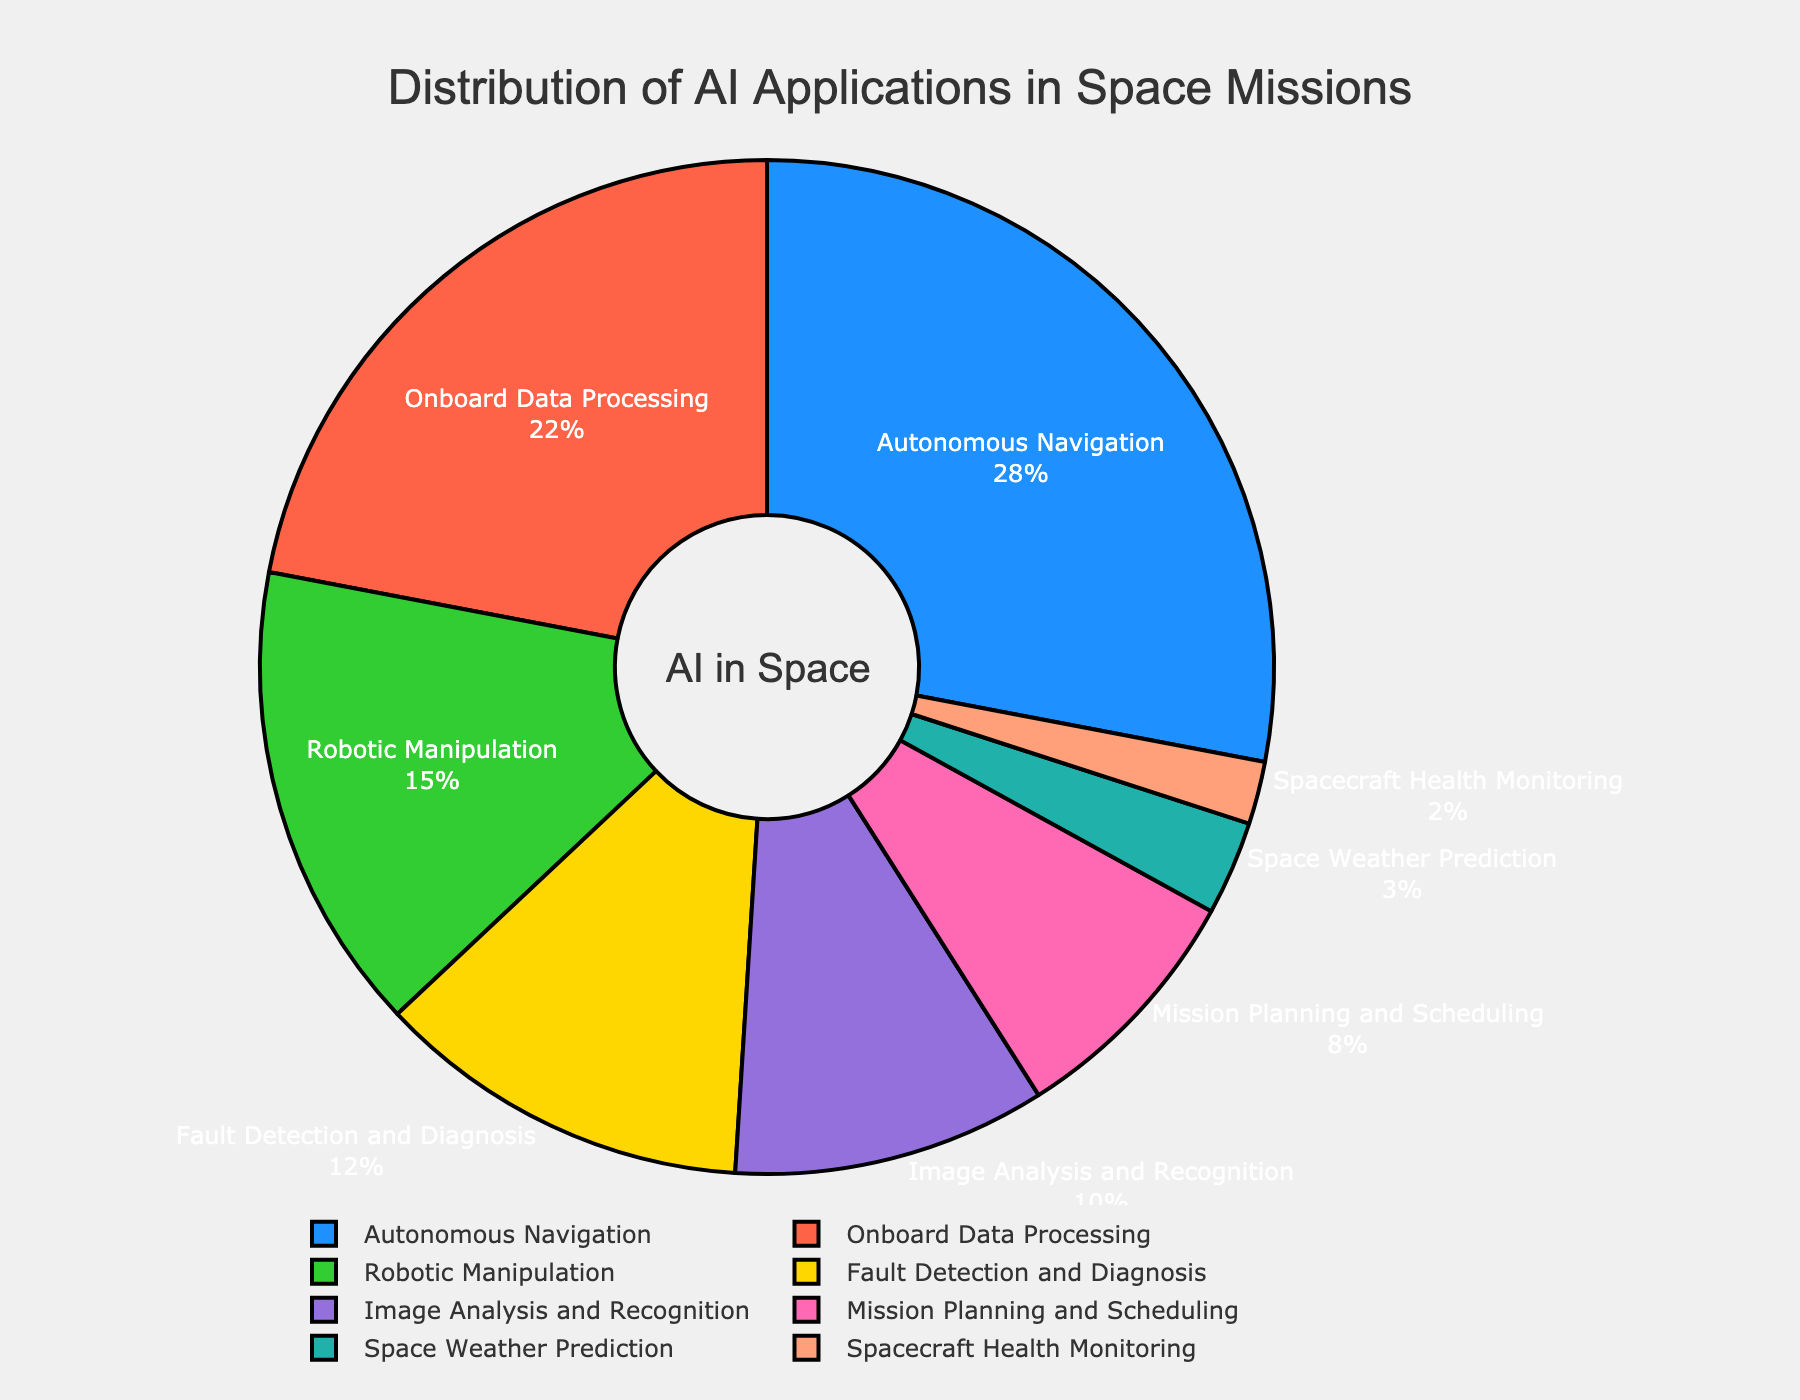What's the most common AI application in space missions? The pie chart labels and percentages show that 'Autonomous Navigation' has the highest percentage of 28%. Compare this to other categories which all have lower percentages.
Answer: Autonomous Navigation Which two applications combined make up exactly half of the AI applications in space missions? Adding the percentages of 'Autonomous Navigation' (28%) and 'Onboard Data Processing' (22%) results in 50%.
Answer: Autonomous Navigation and Onboard Data Processing What is the combined percentage of 'Robotic Manipulation' and 'Image Analysis and Recognition'? The pie chart shows 'Robotic Manipulation' at 15% and 'Image Analysis and Recognition' at 10%. Adding these gives 15% + 10% = 25%.
Answer: 25% Which category has a larger percentage: 'Fault Detection and Diagnosis' or 'Mission Planning and Scheduling'? The chart shows 'Fault Detection and Diagnosis' at 12% and 'Mission Planning and Scheduling' at 8%. 12% is greater than 8%.
Answer: Fault Detection and Diagnosis How much more common is 'Onboard Data Processing' compared to 'Robotic Manipulation'? Comparing the given percentages, 'Onboard Data Processing' is 22% and 'Robotic Manipulation' is 15%. The difference is 22% - 15% = 7%.
Answer: 7% What percentage of AI applications in space missions is dedicated to tasks other than 'Autonomous Navigation' and 'Onboard Data Processing'? Subtract the sum of 'Autonomous Navigation' (28%) and 'Onboard Data Processing' (22%) from 100%. Therefore, 100% - (28% + 22%) = 100% - 50% = 50%.
Answer: 50% Which application has the smallest representation in space missions as shown in the pie chart? The smallest percentage data label on the pie chart is for 'Spacecraft Health Monitoring' at 2%.
Answer: Spacecraft Health Monitoring Among 'Image Analysis and Recognition' and 'Space Weather Prediction', which one occupies a smaller percentage? The chart shows 'Image Analysis and Recognition' at 10% and 'Space Weather Prediction' at 3%. 3% is less than 10%.
Answer: Space Weather Prediction What is the difference in percentage between the applications with the highest and lowest representations? The highest is 'Autonomous Navigation' at 28% and the lowest is 'Spacecraft Health Monitoring' at 2%. The difference is 28% - 2% = 26%.
Answer: 26% 